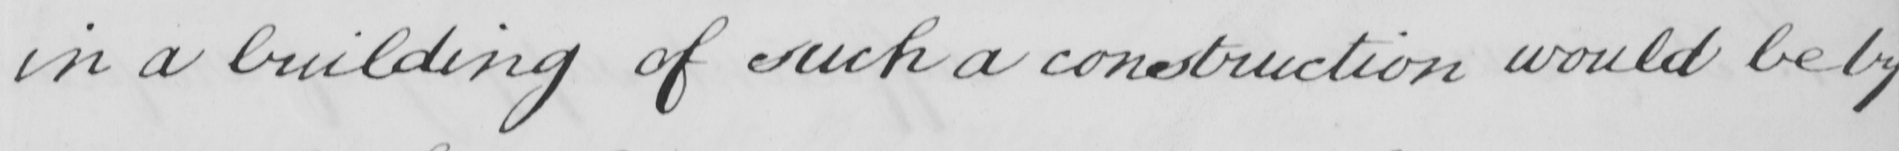What text is written in this handwritten line? in a building of such a construction would be by 